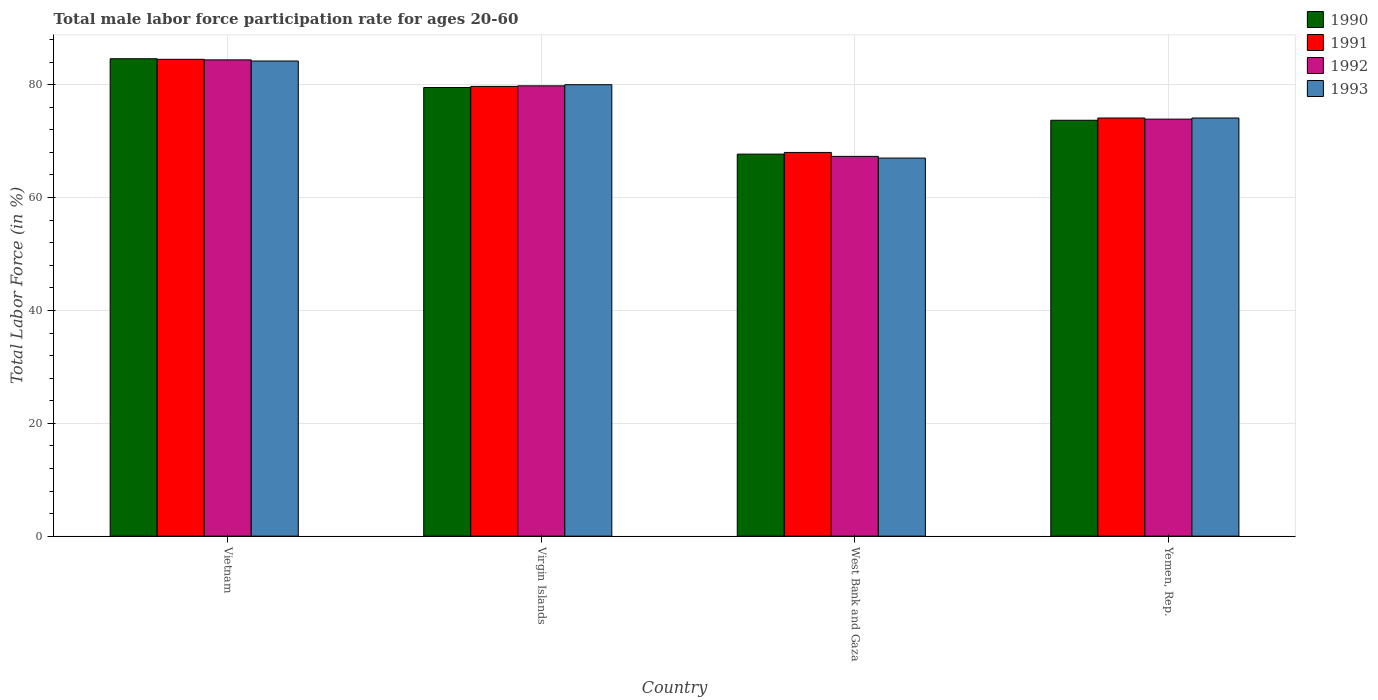How many groups of bars are there?
Provide a short and direct response. 4. Are the number of bars per tick equal to the number of legend labels?
Keep it short and to the point. Yes. How many bars are there on the 1st tick from the left?
Keep it short and to the point. 4. How many bars are there on the 3rd tick from the right?
Your response must be concise. 4. What is the label of the 2nd group of bars from the left?
Your answer should be very brief. Virgin Islands. Across all countries, what is the maximum male labor force participation rate in 1993?
Offer a terse response. 84.2. Across all countries, what is the minimum male labor force participation rate in 1992?
Your answer should be very brief. 67.3. In which country was the male labor force participation rate in 1990 maximum?
Offer a very short reply. Vietnam. In which country was the male labor force participation rate in 1993 minimum?
Your answer should be compact. West Bank and Gaza. What is the total male labor force participation rate in 1993 in the graph?
Provide a short and direct response. 305.3. What is the difference between the male labor force participation rate in 1991 in Vietnam and that in Yemen, Rep.?
Make the answer very short. 10.4. What is the average male labor force participation rate in 1992 per country?
Provide a short and direct response. 76.35. What is the difference between the male labor force participation rate of/in 1993 and male labor force participation rate of/in 1990 in Vietnam?
Provide a succinct answer. -0.4. What is the ratio of the male labor force participation rate in 1991 in Virgin Islands to that in West Bank and Gaza?
Your response must be concise. 1.17. Is the male labor force participation rate in 1993 in West Bank and Gaza less than that in Yemen, Rep.?
Offer a terse response. Yes. Is the difference between the male labor force participation rate in 1993 in Virgin Islands and West Bank and Gaza greater than the difference between the male labor force participation rate in 1990 in Virgin Islands and West Bank and Gaza?
Provide a short and direct response. Yes. What is the difference between the highest and the second highest male labor force participation rate in 1993?
Your answer should be very brief. 5.9. What is the difference between the highest and the lowest male labor force participation rate in 1992?
Your response must be concise. 17.1. In how many countries, is the male labor force participation rate in 1993 greater than the average male labor force participation rate in 1993 taken over all countries?
Ensure brevity in your answer.  2. Is the sum of the male labor force participation rate in 1992 in Virgin Islands and Yemen, Rep. greater than the maximum male labor force participation rate in 1993 across all countries?
Offer a very short reply. Yes. Is it the case that in every country, the sum of the male labor force participation rate in 1993 and male labor force participation rate in 1992 is greater than the sum of male labor force participation rate in 1990 and male labor force participation rate in 1991?
Provide a succinct answer. No. What does the 3rd bar from the left in Yemen, Rep. represents?
Ensure brevity in your answer.  1992. What does the 2nd bar from the right in West Bank and Gaza represents?
Your answer should be compact. 1992. What is the difference between two consecutive major ticks on the Y-axis?
Provide a short and direct response. 20. Are the values on the major ticks of Y-axis written in scientific E-notation?
Your answer should be compact. No. Does the graph contain any zero values?
Provide a succinct answer. No. What is the title of the graph?
Offer a very short reply. Total male labor force participation rate for ages 20-60. Does "1960" appear as one of the legend labels in the graph?
Your response must be concise. No. What is the label or title of the X-axis?
Give a very brief answer. Country. What is the label or title of the Y-axis?
Your answer should be compact. Total Labor Force (in %). What is the Total Labor Force (in %) in 1990 in Vietnam?
Your response must be concise. 84.6. What is the Total Labor Force (in %) of 1991 in Vietnam?
Your answer should be compact. 84.5. What is the Total Labor Force (in %) of 1992 in Vietnam?
Provide a succinct answer. 84.4. What is the Total Labor Force (in %) of 1993 in Vietnam?
Give a very brief answer. 84.2. What is the Total Labor Force (in %) in 1990 in Virgin Islands?
Your response must be concise. 79.5. What is the Total Labor Force (in %) of 1991 in Virgin Islands?
Your answer should be compact. 79.7. What is the Total Labor Force (in %) in 1992 in Virgin Islands?
Provide a succinct answer. 79.8. What is the Total Labor Force (in %) of 1990 in West Bank and Gaza?
Your response must be concise. 67.7. What is the Total Labor Force (in %) of 1991 in West Bank and Gaza?
Give a very brief answer. 68. What is the Total Labor Force (in %) in 1992 in West Bank and Gaza?
Offer a terse response. 67.3. What is the Total Labor Force (in %) of 1990 in Yemen, Rep.?
Offer a terse response. 73.7. What is the Total Labor Force (in %) of 1991 in Yemen, Rep.?
Your response must be concise. 74.1. What is the Total Labor Force (in %) in 1992 in Yemen, Rep.?
Make the answer very short. 73.9. What is the Total Labor Force (in %) of 1993 in Yemen, Rep.?
Offer a very short reply. 74.1. Across all countries, what is the maximum Total Labor Force (in %) of 1990?
Offer a very short reply. 84.6. Across all countries, what is the maximum Total Labor Force (in %) of 1991?
Make the answer very short. 84.5. Across all countries, what is the maximum Total Labor Force (in %) of 1992?
Provide a succinct answer. 84.4. Across all countries, what is the maximum Total Labor Force (in %) of 1993?
Offer a terse response. 84.2. Across all countries, what is the minimum Total Labor Force (in %) of 1990?
Offer a very short reply. 67.7. Across all countries, what is the minimum Total Labor Force (in %) in 1992?
Give a very brief answer. 67.3. What is the total Total Labor Force (in %) of 1990 in the graph?
Provide a succinct answer. 305.5. What is the total Total Labor Force (in %) of 1991 in the graph?
Your answer should be very brief. 306.3. What is the total Total Labor Force (in %) of 1992 in the graph?
Offer a very short reply. 305.4. What is the total Total Labor Force (in %) in 1993 in the graph?
Your answer should be very brief. 305.3. What is the difference between the Total Labor Force (in %) in 1990 in Vietnam and that in Virgin Islands?
Make the answer very short. 5.1. What is the difference between the Total Labor Force (in %) in 1991 in Vietnam and that in Virgin Islands?
Offer a very short reply. 4.8. What is the difference between the Total Labor Force (in %) in 1991 in Vietnam and that in West Bank and Gaza?
Provide a succinct answer. 16.5. What is the difference between the Total Labor Force (in %) of 1992 in Vietnam and that in West Bank and Gaza?
Provide a succinct answer. 17.1. What is the difference between the Total Labor Force (in %) of 1993 in Vietnam and that in West Bank and Gaza?
Ensure brevity in your answer.  17.2. What is the difference between the Total Labor Force (in %) of 1992 in Vietnam and that in Yemen, Rep.?
Give a very brief answer. 10.5. What is the difference between the Total Labor Force (in %) in 1993 in Vietnam and that in Yemen, Rep.?
Provide a succinct answer. 10.1. What is the difference between the Total Labor Force (in %) of 1990 in Virgin Islands and that in West Bank and Gaza?
Provide a short and direct response. 11.8. What is the difference between the Total Labor Force (in %) of 1993 in Virgin Islands and that in West Bank and Gaza?
Provide a short and direct response. 13. What is the difference between the Total Labor Force (in %) in 1990 in Virgin Islands and that in Yemen, Rep.?
Your answer should be compact. 5.8. What is the difference between the Total Labor Force (in %) of 1991 in Virgin Islands and that in Yemen, Rep.?
Keep it short and to the point. 5.6. What is the difference between the Total Labor Force (in %) in 1992 in Virgin Islands and that in Yemen, Rep.?
Provide a short and direct response. 5.9. What is the difference between the Total Labor Force (in %) in 1993 in Virgin Islands and that in Yemen, Rep.?
Give a very brief answer. 5.9. What is the difference between the Total Labor Force (in %) in 1991 in West Bank and Gaza and that in Yemen, Rep.?
Offer a very short reply. -6.1. What is the difference between the Total Labor Force (in %) of 1993 in West Bank and Gaza and that in Yemen, Rep.?
Ensure brevity in your answer.  -7.1. What is the difference between the Total Labor Force (in %) of 1990 in Vietnam and the Total Labor Force (in %) of 1991 in Virgin Islands?
Make the answer very short. 4.9. What is the difference between the Total Labor Force (in %) of 1990 in Vietnam and the Total Labor Force (in %) of 1992 in Virgin Islands?
Your answer should be compact. 4.8. What is the difference between the Total Labor Force (in %) in 1990 in Vietnam and the Total Labor Force (in %) in 1993 in Virgin Islands?
Offer a terse response. 4.6. What is the difference between the Total Labor Force (in %) in 1991 in Vietnam and the Total Labor Force (in %) in 1992 in Virgin Islands?
Offer a terse response. 4.7. What is the difference between the Total Labor Force (in %) of 1992 in Vietnam and the Total Labor Force (in %) of 1993 in Virgin Islands?
Provide a short and direct response. 4.4. What is the difference between the Total Labor Force (in %) of 1990 in Vietnam and the Total Labor Force (in %) of 1992 in West Bank and Gaza?
Your answer should be compact. 17.3. What is the difference between the Total Labor Force (in %) in 1990 in Vietnam and the Total Labor Force (in %) in 1993 in West Bank and Gaza?
Provide a short and direct response. 17.6. What is the difference between the Total Labor Force (in %) in 1991 in Vietnam and the Total Labor Force (in %) in 1992 in West Bank and Gaza?
Keep it short and to the point. 17.2. What is the difference between the Total Labor Force (in %) of 1991 in Vietnam and the Total Labor Force (in %) of 1993 in West Bank and Gaza?
Make the answer very short. 17.5. What is the difference between the Total Labor Force (in %) of 1990 in Vietnam and the Total Labor Force (in %) of 1991 in Yemen, Rep.?
Provide a short and direct response. 10.5. What is the difference between the Total Labor Force (in %) of 1990 in Vietnam and the Total Labor Force (in %) of 1992 in Yemen, Rep.?
Your answer should be compact. 10.7. What is the difference between the Total Labor Force (in %) of 1991 in Vietnam and the Total Labor Force (in %) of 1992 in Yemen, Rep.?
Ensure brevity in your answer.  10.6. What is the difference between the Total Labor Force (in %) in 1991 in Vietnam and the Total Labor Force (in %) in 1993 in Yemen, Rep.?
Provide a short and direct response. 10.4. What is the difference between the Total Labor Force (in %) in 1990 in Virgin Islands and the Total Labor Force (in %) in 1991 in West Bank and Gaza?
Give a very brief answer. 11.5. What is the difference between the Total Labor Force (in %) in 1990 in Virgin Islands and the Total Labor Force (in %) in 1992 in West Bank and Gaza?
Offer a very short reply. 12.2. What is the difference between the Total Labor Force (in %) of 1991 in Virgin Islands and the Total Labor Force (in %) of 1993 in West Bank and Gaza?
Offer a very short reply. 12.7. What is the difference between the Total Labor Force (in %) of 1992 in Virgin Islands and the Total Labor Force (in %) of 1993 in West Bank and Gaza?
Offer a terse response. 12.8. What is the difference between the Total Labor Force (in %) of 1990 in Virgin Islands and the Total Labor Force (in %) of 1991 in Yemen, Rep.?
Ensure brevity in your answer.  5.4. What is the difference between the Total Labor Force (in %) in 1990 in Virgin Islands and the Total Labor Force (in %) in 1992 in Yemen, Rep.?
Offer a terse response. 5.6. What is the difference between the Total Labor Force (in %) of 1991 in Virgin Islands and the Total Labor Force (in %) of 1993 in Yemen, Rep.?
Your answer should be compact. 5.6. What is the difference between the Total Labor Force (in %) of 1991 in West Bank and Gaza and the Total Labor Force (in %) of 1992 in Yemen, Rep.?
Provide a short and direct response. -5.9. What is the average Total Labor Force (in %) of 1990 per country?
Offer a very short reply. 76.38. What is the average Total Labor Force (in %) in 1991 per country?
Your answer should be very brief. 76.58. What is the average Total Labor Force (in %) of 1992 per country?
Give a very brief answer. 76.35. What is the average Total Labor Force (in %) of 1993 per country?
Offer a very short reply. 76.33. What is the difference between the Total Labor Force (in %) of 1990 and Total Labor Force (in %) of 1991 in Vietnam?
Your response must be concise. 0.1. What is the difference between the Total Labor Force (in %) in 1990 and Total Labor Force (in %) in 1992 in Vietnam?
Your response must be concise. 0.2. What is the difference between the Total Labor Force (in %) of 1990 and Total Labor Force (in %) of 1993 in Vietnam?
Keep it short and to the point. 0.4. What is the difference between the Total Labor Force (in %) of 1991 and Total Labor Force (in %) of 1992 in Vietnam?
Your answer should be very brief. 0.1. What is the difference between the Total Labor Force (in %) of 1991 and Total Labor Force (in %) of 1993 in Vietnam?
Ensure brevity in your answer.  0.3. What is the difference between the Total Labor Force (in %) of 1992 and Total Labor Force (in %) of 1993 in Vietnam?
Provide a succinct answer. 0.2. What is the difference between the Total Labor Force (in %) in 1990 and Total Labor Force (in %) in 1991 in Virgin Islands?
Your response must be concise. -0.2. What is the difference between the Total Labor Force (in %) of 1991 and Total Labor Force (in %) of 1992 in Virgin Islands?
Offer a terse response. -0.1. What is the difference between the Total Labor Force (in %) of 1991 and Total Labor Force (in %) of 1993 in Virgin Islands?
Provide a short and direct response. -0.3. What is the difference between the Total Labor Force (in %) of 1990 and Total Labor Force (in %) of 1992 in West Bank and Gaza?
Provide a succinct answer. 0.4. What is the difference between the Total Labor Force (in %) in 1990 and Total Labor Force (in %) in 1993 in West Bank and Gaza?
Provide a succinct answer. 0.7. What is the difference between the Total Labor Force (in %) of 1992 and Total Labor Force (in %) of 1993 in West Bank and Gaza?
Offer a terse response. 0.3. What is the difference between the Total Labor Force (in %) of 1990 and Total Labor Force (in %) of 1991 in Yemen, Rep.?
Keep it short and to the point. -0.4. What is the difference between the Total Labor Force (in %) in 1990 and Total Labor Force (in %) in 1993 in Yemen, Rep.?
Ensure brevity in your answer.  -0.4. What is the difference between the Total Labor Force (in %) in 1991 and Total Labor Force (in %) in 1992 in Yemen, Rep.?
Offer a terse response. 0.2. What is the difference between the Total Labor Force (in %) of 1991 and Total Labor Force (in %) of 1993 in Yemen, Rep.?
Ensure brevity in your answer.  0. What is the difference between the Total Labor Force (in %) of 1992 and Total Labor Force (in %) of 1993 in Yemen, Rep.?
Your response must be concise. -0.2. What is the ratio of the Total Labor Force (in %) in 1990 in Vietnam to that in Virgin Islands?
Keep it short and to the point. 1.06. What is the ratio of the Total Labor Force (in %) of 1991 in Vietnam to that in Virgin Islands?
Give a very brief answer. 1.06. What is the ratio of the Total Labor Force (in %) of 1992 in Vietnam to that in Virgin Islands?
Keep it short and to the point. 1.06. What is the ratio of the Total Labor Force (in %) in 1993 in Vietnam to that in Virgin Islands?
Provide a short and direct response. 1.05. What is the ratio of the Total Labor Force (in %) in 1990 in Vietnam to that in West Bank and Gaza?
Ensure brevity in your answer.  1.25. What is the ratio of the Total Labor Force (in %) of 1991 in Vietnam to that in West Bank and Gaza?
Give a very brief answer. 1.24. What is the ratio of the Total Labor Force (in %) of 1992 in Vietnam to that in West Bank and Gaza?
Ensure brevity in your answer.  1.25. What is the ratio of the Total Labor Force (in %) of 1993 in Vietnam to that in West Bank and Gaza?
Give a very brief answer. 1.26. What is the ratio of the Total Labor Force (in %) in 1990 in Vietnam to that in Yemen, Rep.?
Your answer should be very brief. 1.15. What is the ratio of the Total Labor Force (in %) in 1991 in Vietnam to that in Yemen, Rep.?
Offer a very short reply. 1.14. What is the ratio of the Total Labor Force (in %) in 1992 in Vietnam to that in Yemen, Rep.?
Keep it short and to the point. 1.14. What is the ratio of the Total Labor Force (in %) in 1993 in Vietnam to that in Yemen, Rep.?
Give a very brief answer. 1.14. What is the ratio of the Total Labor Force (in %) in 1990 in Virgin Islands to that in West Bank and Gaza?
Offer a terse response. 1.17. What is the ratio of the Total Labor Force (in %) in 1991 in Virgin Islands to that in West Bank and Gaza?
Your response must be concise. 1.17. What is the ratio of the Total Labor Force (in %) of 1992 in Virgin Islands to that in West Bank and Gaza?
Your answer should be compact. 1.19. What is the ratio of the Total Labor Force (in %) of 1993 in Virgin Islands to that in West Bank and Gaza?
Provide a succinct answer. 1.19. What is the ratio of the Total Labor Force (in %) in 1990 in Virgin Islands to that in Yemen, Rep.?
Your response must be concise. 1.08. What is the ratio of the Total Labor Force (in %) of 1991 in Virgin Islands to that in Yemen, Rep.?
Your answer should be compact. 1.08. What is the ratio of the Total Labor Force (in %) of 1992 in Virgin Islands to that in Yemen, Rep.?
Offer a very short reply. 1.08. What is the ratio of the Total Labor Force (in %) of 1993 in Virgin Islands to that in Yemen, Rep.?
Keep it short and to the point. 1.08. What is the ratio of the Total Labor Force (in %) in 1990 in West Bank and Gaza to that in Yemen, Rep.?
Provide a succinct answer. 0.92. What is the ratio of the Total Labor Force (in %) in 1991 in West Bank and Gaza to that in Yemen, Rep.?
Provide a succinct answer. 0.92. What is the ratio of the Total Labor Force (in %) in 1992 in West Bank and Gaza to that in Yemen, Rep.?
Your response must be concise. 0.91. What is the ratio of the Total Labor Force (in %) in 1993 in West Bank and Gaza to that in Yemen, Rep.?
Provide a succinct answer. 0.9. What is the difference between the highest and the second highest Total Labor Force (in %) of 1992?
Offer a terse response. 4.6. What is the difference between the highest and the lowest Total Labor Force (in %) of 1993?
Your answer should be compact. 17.2. 